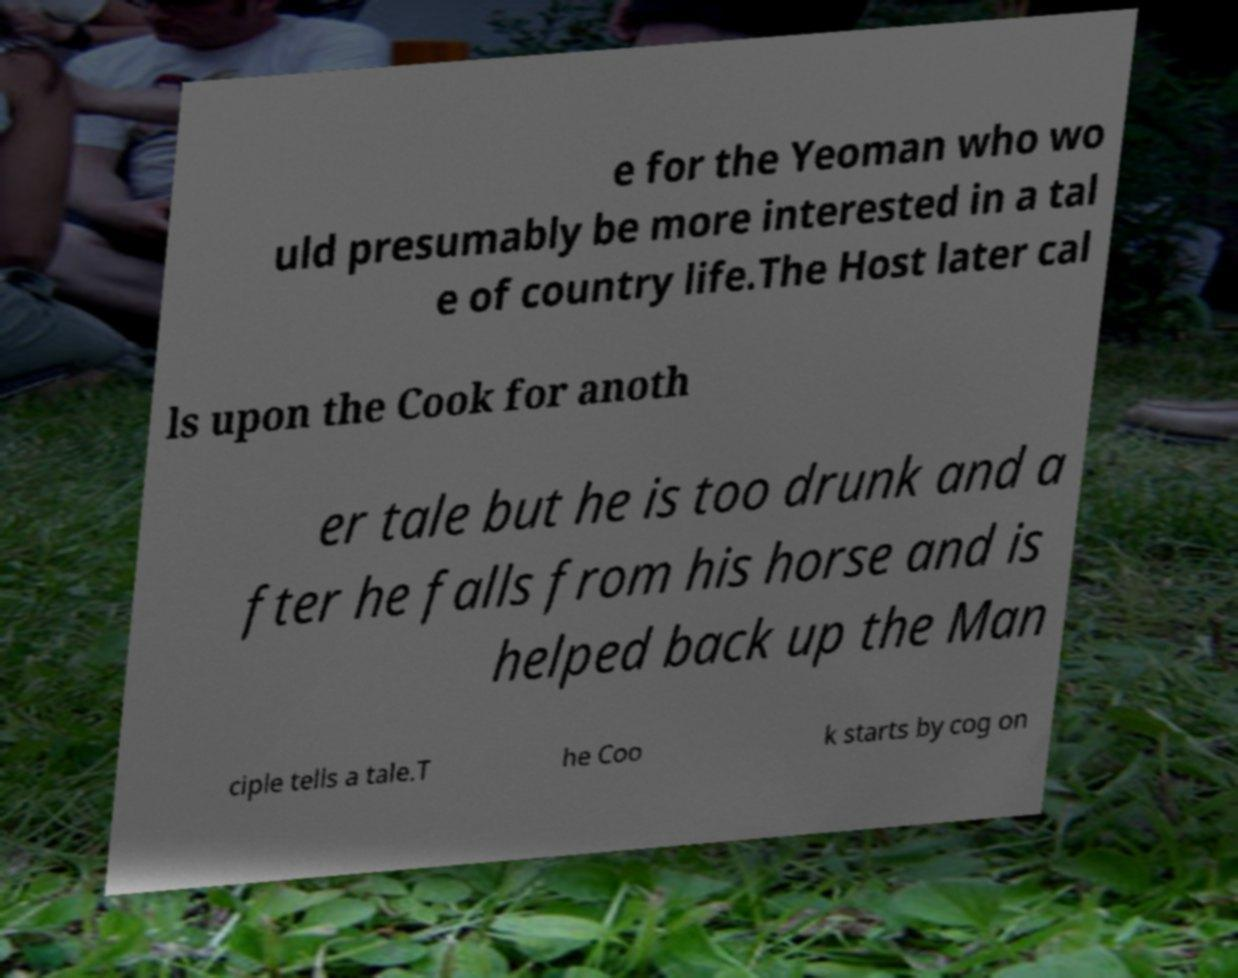Could you extract and type out the text from this image? e for the Yeoman who wo uld presumably be more interested in a tal e of country life.The Host later cal ls upon the Cook for anoth er tale but he is too drunk and a fter he falls from his horse and is helped back up the Man ciple tells a tale.T he Coo k starts by cog on 